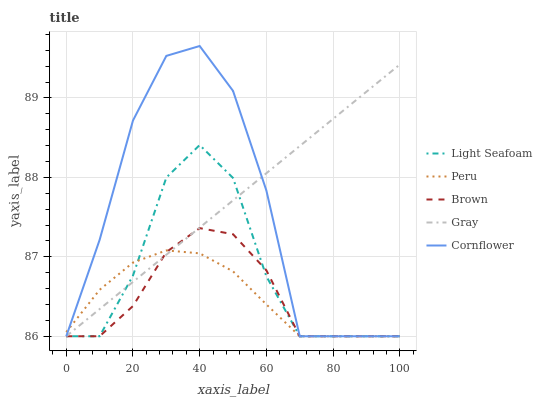Does Light Seafoam have the minimum area under the curve?
Answer yes or no. No. Does Light Seafoam have the maximum area under the curve?
Answer yes or no. No. Is Light Seafoam the smoothest?
Answer yes or no. No. Is Light Seafoam the roughest?
Answer yes or no. No. Does Light Seafoam have the highest value?
Answer yes or no. No. 